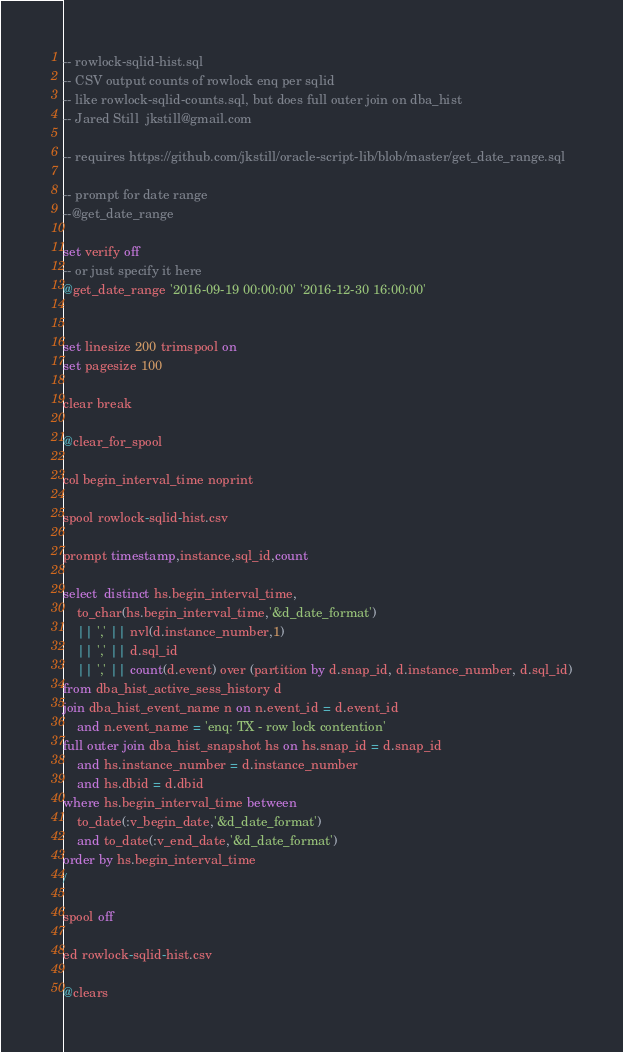<code> <loc_0><loc_0><loc_500><loc_500><_SQL_>
-- rowlock-sqlid-hist.sql
-- CSV output counts of rowlock enq per sqlid
-- like rowlock-sqlid-counts.sql, but does full outer join on dba_hist
-- Jared Still  jkstill@gmail.com

-- requires https://github.com/jkstill/oracle-script-lib/blob/master/get_date_range.sql

-- prompt for date range
--@get_date_range 

set verify off
-- or just specify it here
@get_date_range '2016-09-19 00:00:00' '2016-12-30 16:00:00'


set linesize 200 trimspool on
set pagesize 100 

clear break

@clear_for_spool

col begin_interval_time noprint

spool rowlock-sqlid-hist.csv

prompt timestamp,instance,sql_id,count

select  distinct hs.begin_interval_time,
	to_char(hs.begin_interval_time,'&d_date_format')
	|| ',' || nvl(d.instance_number,1)
	|| ',' || d.sql_id
	|| ',' || count(d.event) over (partition by d.snap_id, d.instance_number, d.sql_id)
from dba_hist_active_sess_history d
join dba_hist_event_name n on n.event_id = d.event_id
	and n.event_name = 'enq: TX - row lock contention'
full outer join dba_hist_snapshot hs on hs.snap_id = d.snap_id
	and hs.instance_number = d.instance_number
	and hs.dbid = d.dbid
where hs.begin_interval_time between
	to_date(:v_begin_date,'&d_date_format')
	and to_date(:v_end_date,'&d_date_format')
order by hs.begin_interval_time
/

spool off

ed rowlock-sqlid-hist.csv

@clears

</code> 